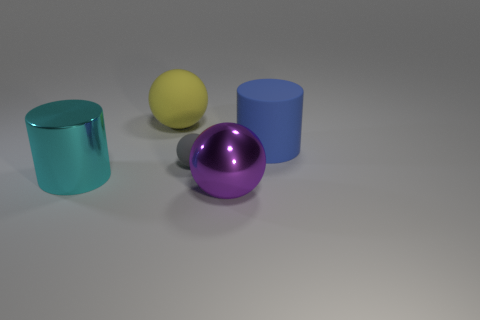Does the large cyan cylinder have the same material as the gray sphere?
Give a very brief answer. No. Does the tiny gray matte thing have the same shape as the big blue thing?
Make the answer very short. No. Are there the same number of small gray balls that are in front of the cyan metal cylinder and objects left of the yellow thing?
Ensure brevity in your answer.  No. The large object that is the same material as the large purple sphere is what color?
Provide a succinct answer. Cyan. How many gray objects are made of the same material as the large blue cylinder?
Offer a very short reply. 1. There is a large cylinder to the left of the tiny matte ball; is it the same color as the large shiny sphere?
Your response must be concise. No. What number of small brown shiny objects have the same shape as the gray object?
Offer a terse response. 0. Is the number of big shiny cylinders that are behind the gray rubber thing the same as the number of cylinders?
Your answer should be compact. No. The matte sphere that is the same size as the cyan metal object is what color?
Give a very brief answer. Yellow. Are there any other big things that have the same shape as the blue matte object?
Make the answer very short. Yes. 